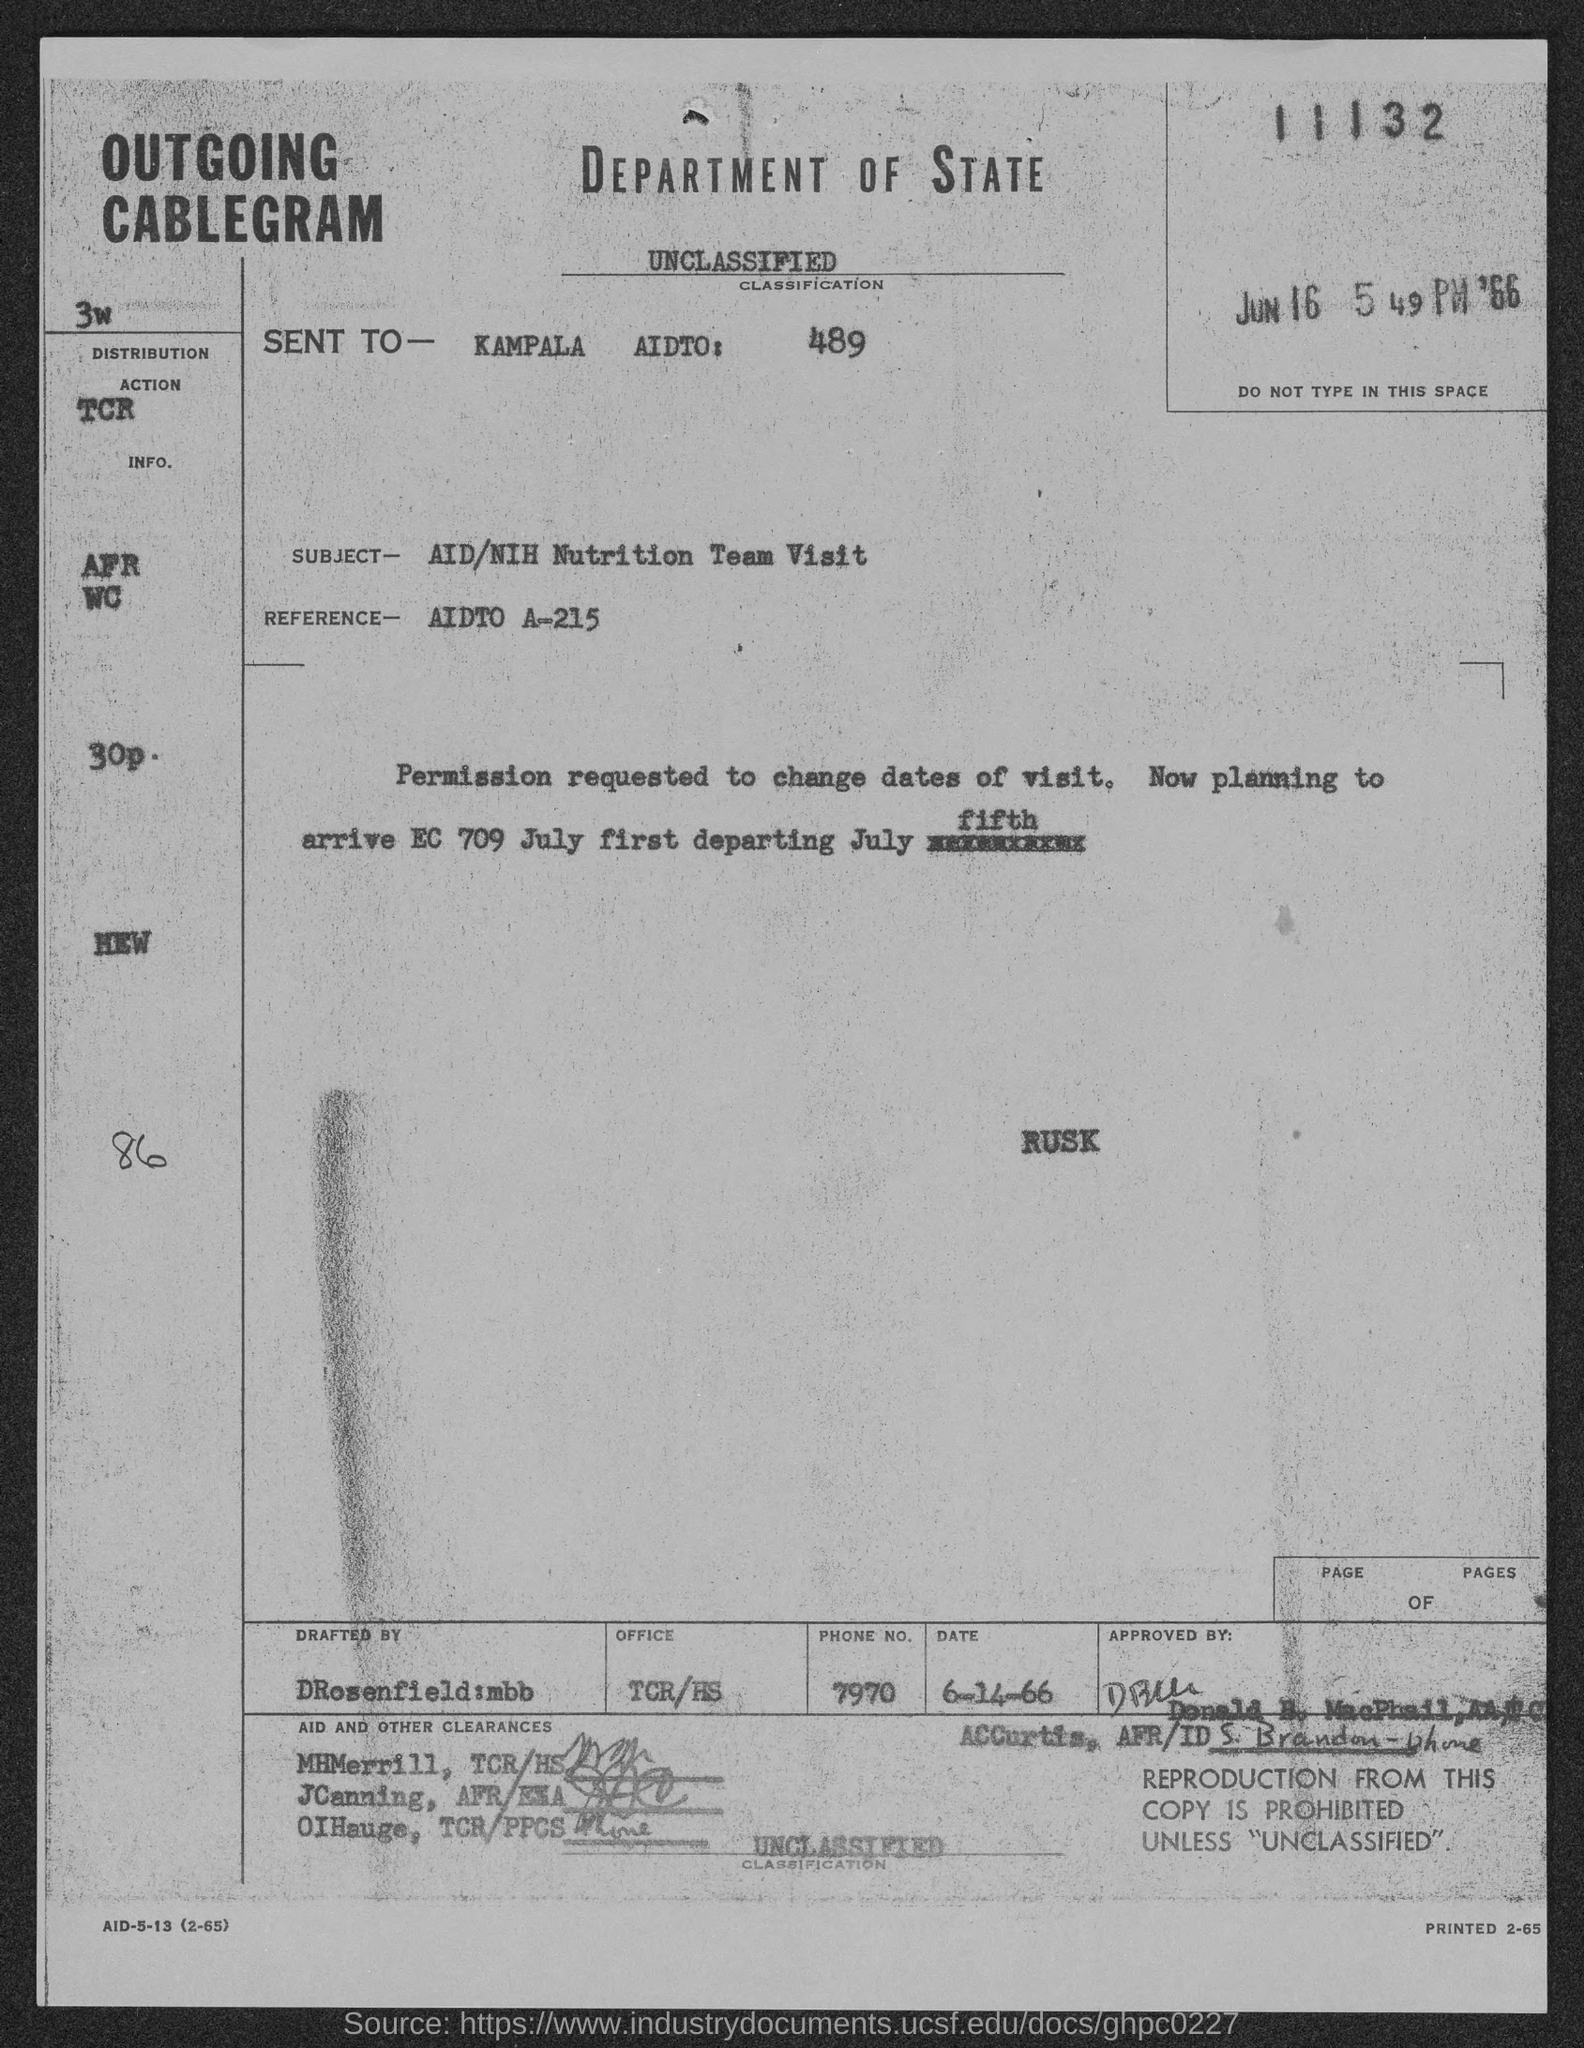Specify some key components in this picture. The number mentioned at the top of the page is 11132. The reference mentioned in the given page is AIDTO A-215. The phone number mentioned in the given form is 7970. The subject mentioned in the given page is the AID/NIH nutrition team's visit. 